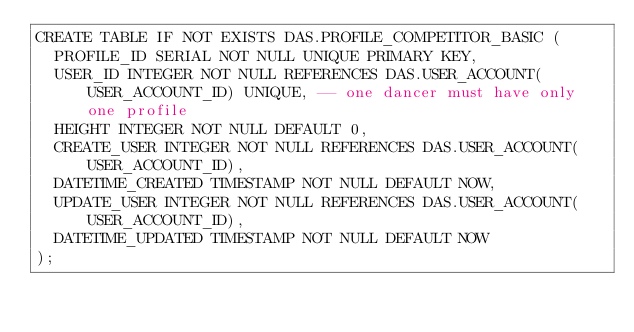<code> <loc_0><loc_0><loc_500><loc_500><_SQL_>CREATE TABLE IF NOT EXISTS DAS.PROFILE_COMPETITOR_BASIC (
  PROFILE_ID SERIAL NOT NULL UNIQUE PRIMARY KEY,
  USER_ID INTEGER NOT NULL REFERENCES DAS.USER_ACCOUNT(USER_ACCOUNT_ID) UNIQUE, -- one dancer must have only one profile
  HEIGHT INTEGER NOT NULL DEFAULT 0,
  CREATE_USER INTEGER NOT NULL REFERENCES DAS.USER_ACCOUNT(USER_ACCOUNT_ID),
  DATETIME_CREATED TIMESTAMP NOT NULL DEFAULT NOW,
  UPDATE_USER INTEGER NOT NULL REFERENCES DAS.USER_ACCOUNT(USER_ACCOUNT_ID),
  DATETIME_UPDATED TIMESTAMP NOT NULL DEFAULT NOW
);</code> 